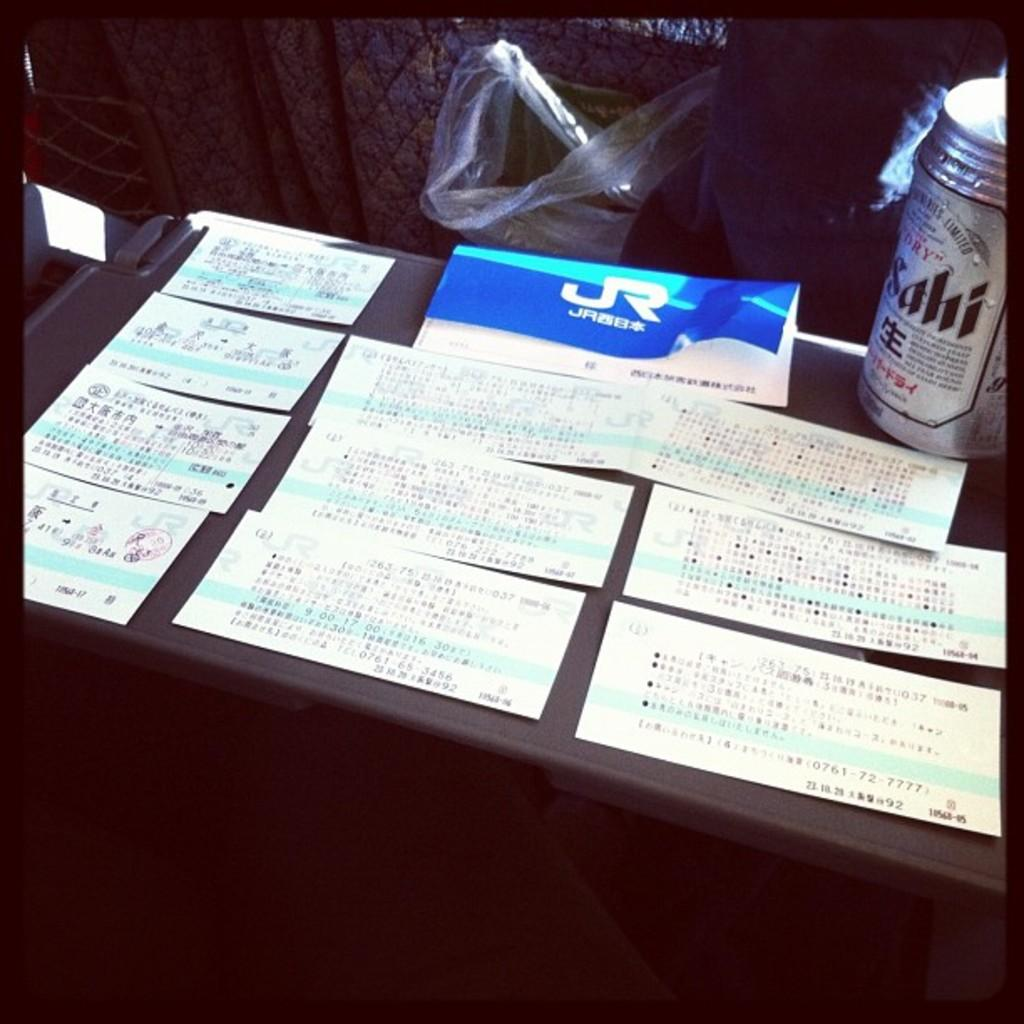<image>
Create a compact narrative representing the image presented. A table has lots of tickets and a can of Sahi beer. 